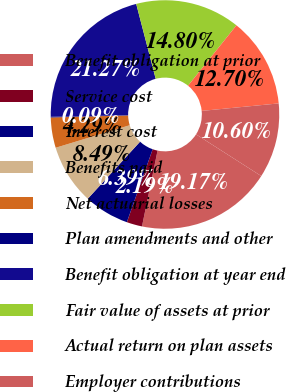Convert chart. <chart><loc_0><loc_0><loc_500><loc_500><pie_chart><fcel>Benefit obligation at prior<fcel>Service cost<fcel>Interest cost<fcel>Benefits paid<fcel>Net actuarial losses<fcel>Plan amendments and other<fcel>Benefit obligation at year end<fcel>Fair value of assets at prior<fcel>Actual return on plan assets<fcel>Employer contributions<nl><fcel>19.17%<fcel>2.19%<fcel>6.39%<fcel>8.49%<fcel>4.29%<fcel>0.09%<fcel>21.27%<fcel>14.8%<fcel>12.7%<fcel>10.6%<nl></chart> 